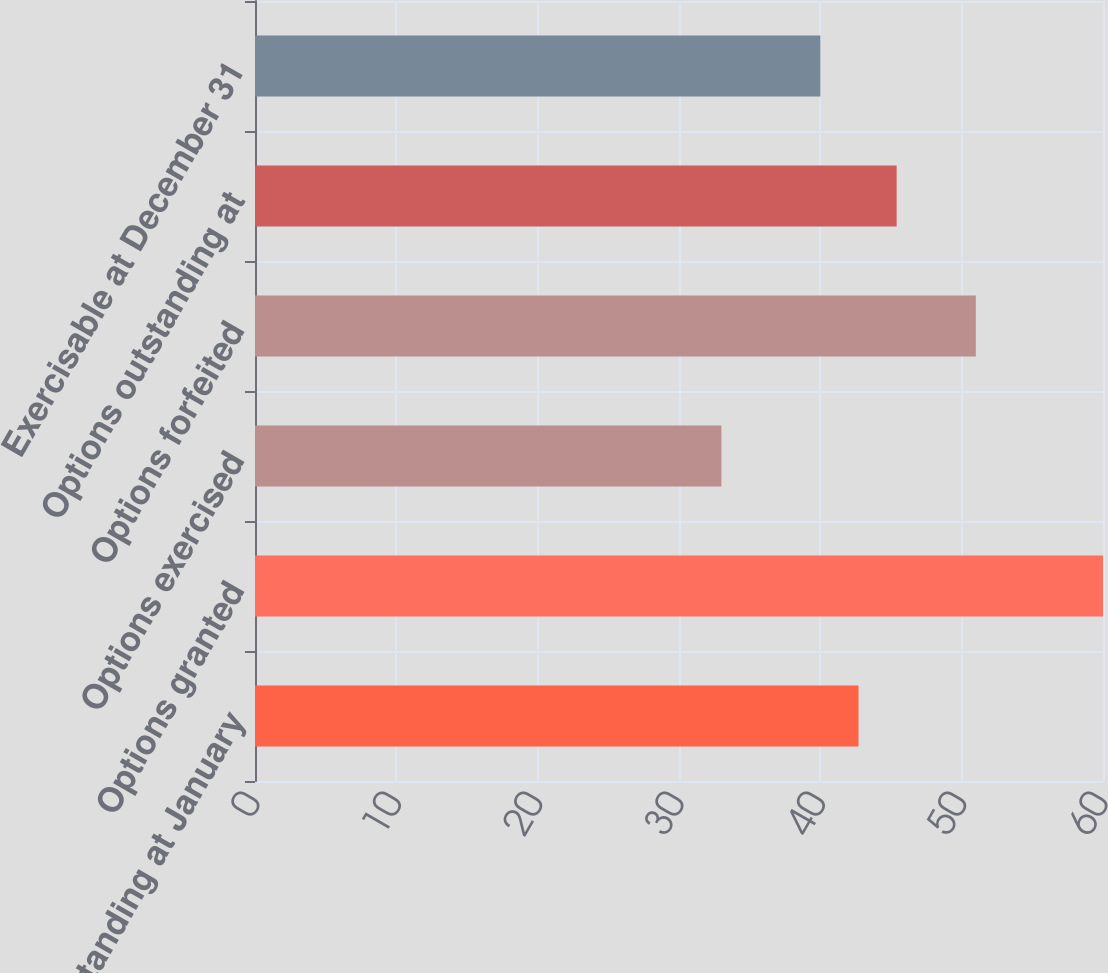Convert chart to OTSL. <chart><loc_0><loc_0><loc_500><loc_500><bar_chart><fcel>Options outstanding at January<fcel>Options granted<fcel>Options exercised<fcel>Options forfeited<fcel>Options outstanding at<fcel>Exercisable at December 31<nl><fcel>42.7<fcel>60<fcel>33<fcel>51<fcel>45.4<fcel>40<nl></chart> 